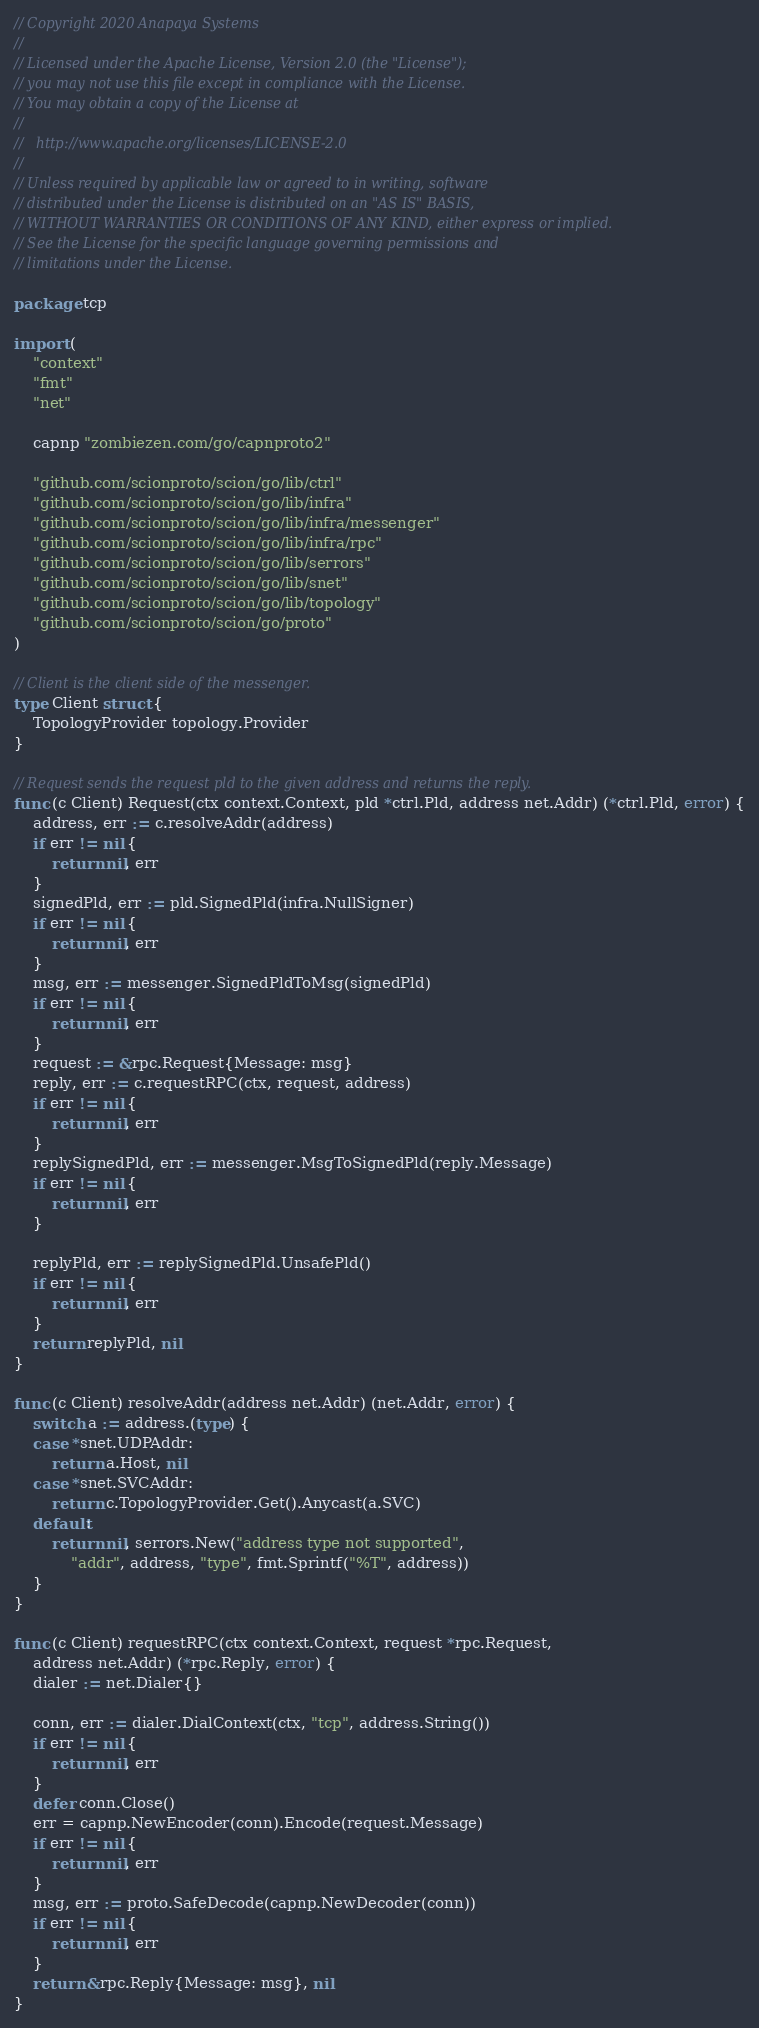<code> <loc_0><loc_0><loc_500><loc_500><_Go_>// Copyright 2020 Anapaya Systems
//
// Licensed under the Apache License, Version 2.0 (the "License");
// you may not use this file except in compliance with the License.
// You may obtain a copy of the License at
//
//   http://www.apache.org/licenses/LICENSE-2.0
//
// Unless required by applicable law or agreed to in writing, software
// distributed under the License is distributed on an "AS IS" BASIS,
// WITHOUT WARRANTIES OR CONDITIONS OF ANY KIND, either express or implied.
// See the License for the specific language governing permissions and
// limitations under the License.

package tcp

import (
	"context"
	"fmt"
	"net"

	capnp "zombiezen.com/go/capnproto2"

	"github.com/scionproto/scion/go/lib/ctrl"
	"github.com/scionproto/scion/go/lib/infra"
	"github.com/scionproto/scion/go/lib/infra/messenger"
	"github.com/scionproto/scion/go/lib/infra/rpc"
	"github.com/scionproto/scion/go/lib/serrors"
	"github.com/scionproto/scion/go/lib/snet"
	"github.com/scionproto/scion/go/lib/topology"
	"github.com/scionproto/scion/go/proto"
)

// Client is the client side of the messenger.
type Client struct {
	TopologyProvider topology.Provider
}

// Request sends the request pld to the given address and returns the reply.
func (c Client) Request(ctx context.Context, pld *ctrl.Pld, address net.Addr) (*ctrl.Pld, error) {
	address, err := c.resolveAddr(address)
	if err != nil {
		return nil, err
	}
	signedPld, err := pld.SignedPld(infra.NullSigner)
	if err != nil {
		return nil, err
	}
	msg, err := messenger.SignedPldToMsg(signedPld)
	if err != nil {
		return nil, err
	}
	request := &rpc.Request{Message: msg}
	reply, err := c.requestRPC(ctx, request, address)
	if err != nil {
		return nil, err
	}
	replySignedPld, err := messenger.MsgToSignedPld(reply.Message)
	if err != nil {
		return nil, err
	}

	replyPld, err := replySignedPld.UnsafePld()
	if err != nil {
		return nil, err
	}
	return replyPld, nil
}

func (c Client) resolveAddr(address net.Addr) (net.Addr, error) {
	switch a := address.(type) {
	case *snet.UDPAddr:
		return a.Host, nil
	case *snet.SVCAddr:
		return c.TopologyProvider.Get().Anycast(a.SVC)
	default:
		return nil, serrors.New("address type not supported",
			"addr", address, "type", fmt.Sprintf("%T", address))
	}
}

func (c Client) requestRPC(ctx context.Context, request *rpc.Request,
	address net.Addr) (*rpc.Reply, error) {
	dialer := net.Dialer{}

	conn, err := dialer.DialContext(ctx, "tcp", address.String())
	if err != nil {
		return nil, err
	}
	defer conn.Close()
	err = capnp.NewEncoder(conn).Encode(request.Message)
	if err != nil {
		return nil, err
	}
	msg, err := proto.SafeDecode(capnp.NewDecoder(conn))
	if err != nil {
		return nil, err
	}
	return &rpc.Reply{Message: msg}, nil
}
</code> 